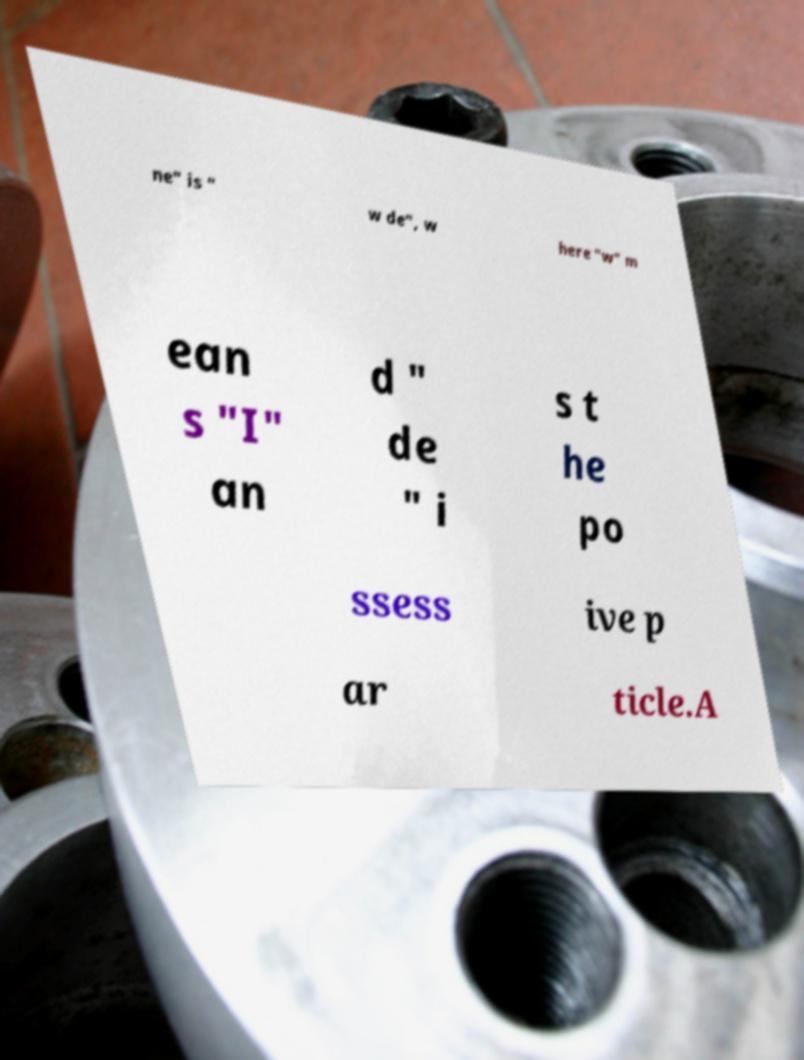For documentation purposes, I need the text within this image transcribed. Could you provide that? ne" is " w de", w here "w" m ean s "I" an d " de " i s t he po ssess ive p ar ticle.A 